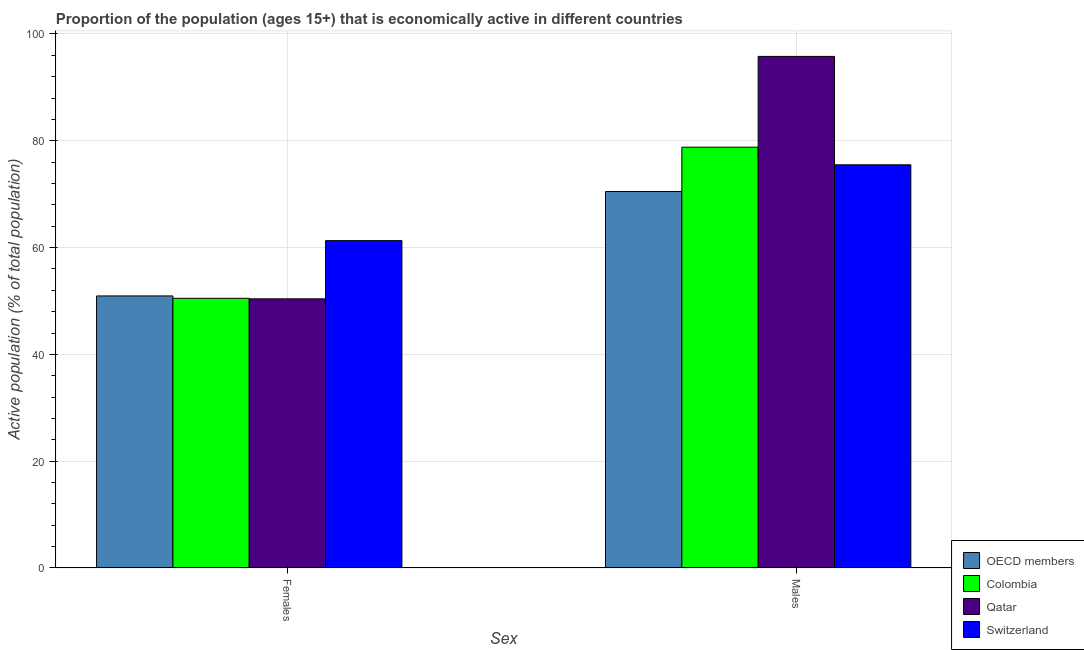Are the number of bars on each tick of the X-axis equal?
Provide a short and direct response. Yes. How many bars are there on the 1st tick from the right?
Provide a short and direct response. 4. What is the label of the 2nd group of bars from the left?
Provide a succinct answer. Males. What is the percentage of economically active male population in OECD members?
Provide a succinct answer. 70.49. Across all countries, what is the maximum percentage of economically active male population?
Offer a terse response. 95.8. Across all countries, what is the minimum percentage of economically active female population?
Ensure brevity in your answer.  50.4. In which country was the percentage of economically active female population maximum?
Provide a succinct answer. Switzerland. What is the total percentage of economically active female population in the graph?
Offer a very short reply. 213.14. What is the difference between the percentage of economically active male population in Switzerland and that in OECD members?
Provide a succinct answer. 5.01. What is the difference between the percentage of economically active female population in Switzerland and the percentage of economically active male population in Colombia?
Give a very brief answer. -17.5. What is the average percentage of economically active male population per country?
Give a very brief answer. 80.15. What is the difference between the percentage of economically active female population and percentage of economically active male population in OECD members?
Keep it short and to the point. -19.55. What is the ratio of the percentage of economically active female population in OECD members to that in Colombia?
Your answer should be compact. 1.01. Is the percentage of economically active female population in Colombia less than that in Qatar?
Provide a short and direct response. No. In how many countries, is the percentage of economically active male population greater than the average percentage of economically active male population taken over all countries?
Provide a succinct answer. 1. What does the 3rd bar from the left in Females represents?
Your answer should be compact. Qatar. How many countries are there in the graph?
Keep it short and to the point. 4. What is the difference between two consecutive major ticks on the Y-axis?
Ensure brevity in your answer.  20. Are the values on the major ticks of Y-axis written in scientific E-notation?
Your response must be concise. No. Does the graph contain grids?
Your response must be concise. Yes. Where does the legend appear in the graph?
Give a very brief answer. Bottom right. How many legend labels are there?
Give a very brief answer. 4. How are the legend labels stacked?
Provide a short and direct response. Vertical. What is the title of the graph?
Offer a very short reply. Proportion of the population (ages 15+) that is economically active in different countries. What is the label or title of the X-axis?
Provide a succinct answer. Sex. What is the label or title of the Y-axis?
Your answer should be compact. Active population (% of total population). What is the Active population (% of total population) of OECD members in Females?
Keep it short and to the point. 50.94. What is the Active population (% of total population) in Colombia in Females?
Your answer should be compact. 50.5. What is the Active population (% of total population) of Qatar in Females?
Ensure brevity in your answer.  50.4. What is the Active population (% of total population) in Switzerland in Females?
Make the answer very short. 61.3. What is the Active population (% of total population) of OECD members in Males?
Provide a short and direct response. 70.49. What is the Active population (% of total population) in Colombia in Males?
Your answer should be compact. 78.8. What is the Active population (% of total population) of Qatar in Males?
Your answer should be compact. 95.8. What is the Active population (% of total population) in Switzerland in Males?
Offer a terse response. 75.5. Across all Sex, what is the maximum Active population (% of total population) in OECD members?
Offer a terse response. 70.49. Across all Sex, what is the maximum Active population (% of total population) of Colombia?
Keep it short and to the point. 78.8. Across all Sex, what is the maximum Active population (% of total population) in Qatar?
Your answer should be compact. 95.8. Across all Sex, what is the maximum Active population (% of total population) in Switzerland?
Offer a very short reply. 75.5. Across all Sex, what is the minimum Active population (% of total population) of OECD members?
Give a very brief answer. 50.94. Across all Sex, what is the minimum Active population (% of total population) of Colombia?
Give a very brief answer. 50.5. Across all Sex, what is the minimum Active population (% of total population) in Qatar?
Offer a terse response. 50.4. Across all Sex, what is the minimum Active population (% of total population) of Switzerland?
Give a very brief answer. 61.3. What is the total Active population (% of total population) of OECD members in the graph?
Your response must be concise. 121.44. What is the total Active population (% of total population) in Colombia in the graph?
Provide a short and direct response. 129.3. What is the total Active population (% of total population) of Qatar in the graph?
Your answer should be very brief. 146.2. What is the total Active population (% of total population) of Switzerland in the graph?
Offer a terse response. 136.8. What is the difference between the Active population (% of total population) of OECD members in Females and that in Males?
Offer a very short reply. -19.55. What is the difference between the Active population (% of total population) in Colombia in Females and that in Males?
Keep it short and to the point. -28.3. What is the difference between the Active population (% of total population) in Qatar in Females and that in Males?
Keep it short and to the point. -45.4. What is the difference between the Active population (% of total population) of Switzerland in Females and that in Males?
Your answer should be very brief. -14.2. What is the difference between the Active population (% of total population) of OECD members in Females and the Active population (% of total population) of Colombia in Males?
Your answer should be compact. -27.86. What is the difference between the Active population (% of total population) in OECD members in Females and the Active population (% of total population) in Qatar in Males?
Give a very brief answer. -44.86. What is the difference between the Active population (% of total population) in OECD members in Females and the Active population (% of total population) in Switzerland in Males?
Provide a short and direct response. -24.56. What is the difference between the Active population (% of total population) of Colombia in Females and the Active population (% of total population) of Qatar in Males?
Ensure brevity in your answer.  -45.3. What is the difference between the Active population (% of total population) in Qatar in Females and the Active population (% of total population) in Switzerland in Males?
Ensure brevity in your answer.  -25.1. What is the average Active population (% of total population) of OECD members per Sex?
Your answer should be very brief. 60.72. What is the average Active population (% of total population) in Colombia per Sex?
Your answer should be compact. 64.65. What is the average Active population (% of total population) of Qatar per Sex?
Offer a terse response. 73.1. What is the average Active population (% of total population) in Switzerland per Sex?
Your answer should be very brief. 68.4. What is the difference between the Active population (% of total population) of OECD members and Active population (% of total population) of Colombia in Females?
Provide a short and direct response. 0.44. What is the difference between the Active population (% of total population) of OECD members and Active population (% of total population) of Qatar in Females?
Make the answer very short. 0.54. What is the difference between the Active population (% of total population) of OECD members and Active population (% of total population) of Switzerland in Females?
Make the answer very short. -10.36. What is the difference between the Active population (% of total population) of Colombia and Active population (% of total population) of Switzerland in Females?
Provide a short and direct response. -10.8. What is the difference between the Active population (% of total population) in Qatar and Active population (% of total population) in Switzerland in Females?
Give a very brief answer. -10.9. What is the difference between the Active population (% of total population) of OECD members and Active population (% of total population) of Colombia in Males?
Your answer should be compact. -8.31. What is the difference between the Active population (% of total population) of OECD members and Active population (% of total population) of Qatar in Males?
Provide a succinct answer. -25.31. What is the difference between the Active population (% of total population) of OECD members and Active population (% of total population) of Switzerland in Males?
Provide a short and direct response. -5.01. What is the difference between the Active population (% of total population) in Colombia and Active population (% of total population) in Qatar in Males?
Provide a succinct answer. -17. What is the difference between the Active population (% of total population) of Qatar and Active population (% of total population) of Switzerland in Males?
Make the answer very short. 20.3. What is the ratio of the Active population (% of total population) in OECD members in Females to that in Males?
Provide a succinct answer. 0.72. What is the ratio of the Active population (% of total population) of Colombia in Females to that in Males?
Make the answer very short. 0.64. What is the ratio of the Active population (% of total population) in Qatar in Females to that in Males?
Keep it short and to the point. 0.53. What is the ratio of the Active population (% of total population) in Switzerland in Females to that in Males?
Make the answer very short. 0.81. What is the difference between the highest and the second highest Active population (% of total population) of OECD members?
Your response must be concise. 19.55. What is the difference between the highest and the second highest Active population (% of total population) of Colombia?
Your answer should be very brief. 28.3. What is the difference between the highest and the second highest Active population (% of total population) in Qatar?
Your answer should be compact. 45.4. What is the difference between the highest and the lowest Active population (% of total population) of OECD members?
Give a very brief answer. 19.55. What is the difference between the highest and the lowest Active population (% of total population) in Colombia?
Your answer should be compact. 28.3. What is the difference between the highest and the lowest Active population (% of total population) of Qatar?
Provide a short and direct response. 45.4. 